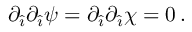Convert formula to latex. <formula><loc_0><loc_0><loc_500><loc_500>\partial _ { \hat { \imath } } \partial _ { \hat { \imath } } \psi = \partial _ { \hat { \imath } } \partial _ { \hat { \imath } } \chi = 0 \, .</formula> 